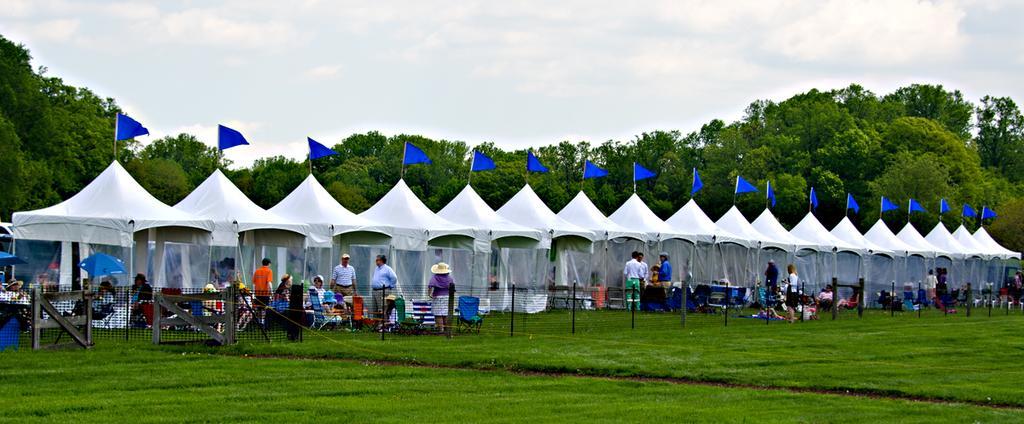How would you summarize this image in a sentence or two? In this image there are tents and there are flags on top of the tents and there are a few people sitting on chairs and there are some people standing in front of the tents, in front of them there is a closed mesh fence, in front of the image there is grass on the surface, in the background of the image there are trees, at the top of the image there are clouds in the sky. 